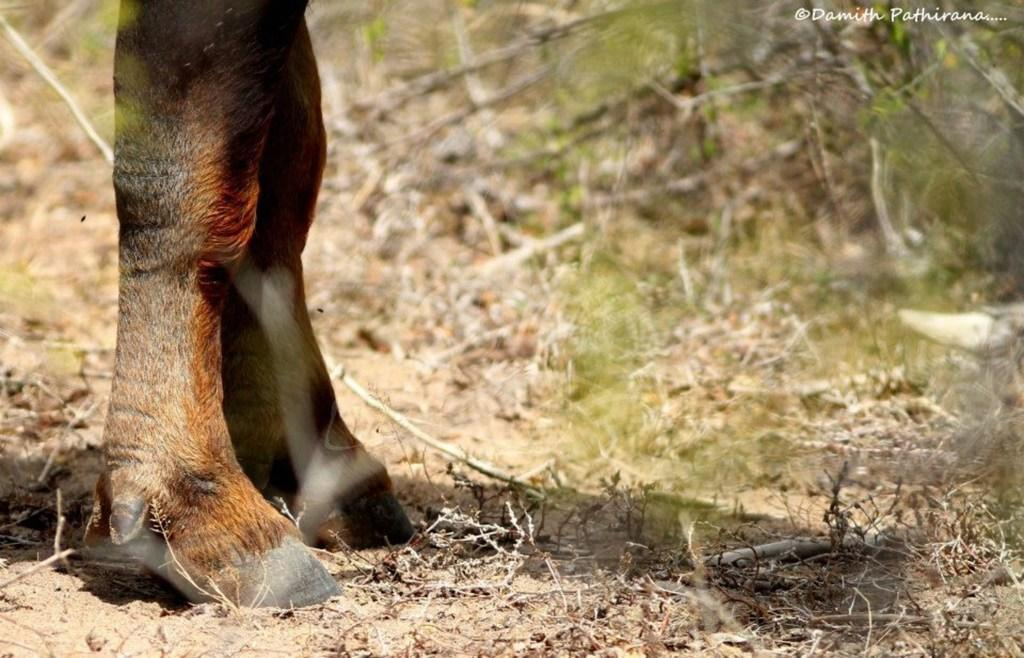What can be found in the foreground of the picture? In the foreground of the picture, there are twigs, sand, dry grass, and the legs of an animal. Can you describe the texture of the foreground? The foreground consists of twigs, sand, and dry grass, which suggests a rough and uneven texture. What is the condition of the background in the image? The background of the image is blurred. What is the price of the stove visible in the image? A: There is no stove present in the image; it features twigs, sand, dry grass, and the legs of an animal in the foreground. 